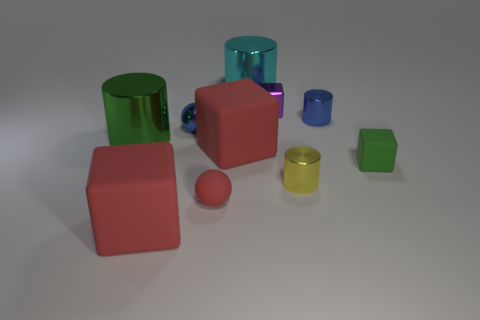There is a blue thing on the left side of the small yellow thing; is its size the same as the red rubber thing on the left side of the tiny red sphere?
Your answer should be compact. No. What number of other things are the same size as the purple metallic thing?
Keep it short and to the point. 5. There is a tiny blue metallic object that is on the left side of the blue cylinder; what number of tiny shiny things are behind it?
Make the answer very short. 2. Are there fewer big metal things that are in front of the matte sphere than cyan shiny cylinders?
Keep it short and to the point. Yes. There is a large metal thing behind the green object to the left of the shiny cylinder behind the purple thing; what is its shape?
Your answer should be very brief. Cylinder. Does the tiny yellow metallic thing have the same shape as the small red thing?
Your answer should be compact. No. What number of other things are the same shape as the big green metallic object?
Offer a terse response. 3. There is a matte block that is the same size as the purple thing; what is its color?
Ensure brevity in your answer.  Green. Is the number of big rubber objects right of the cyan thing the same as the number of small cyan balls?
Give a very brief answer. Yes. What shape is the small metallic object that is both in front of the purple shiny thing and on the left side of the small yellow metallic cylinder?
Give a very brief answer. Sphere. 